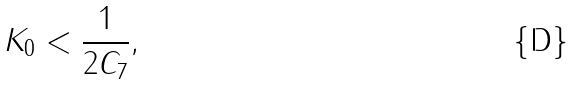Convert formula to latex. <formula><loc_0><loc_0><loc_500><loc_500>K _ { 0 } < \frac { 1 } { 2 C _ { 7 } } ,</formula> 